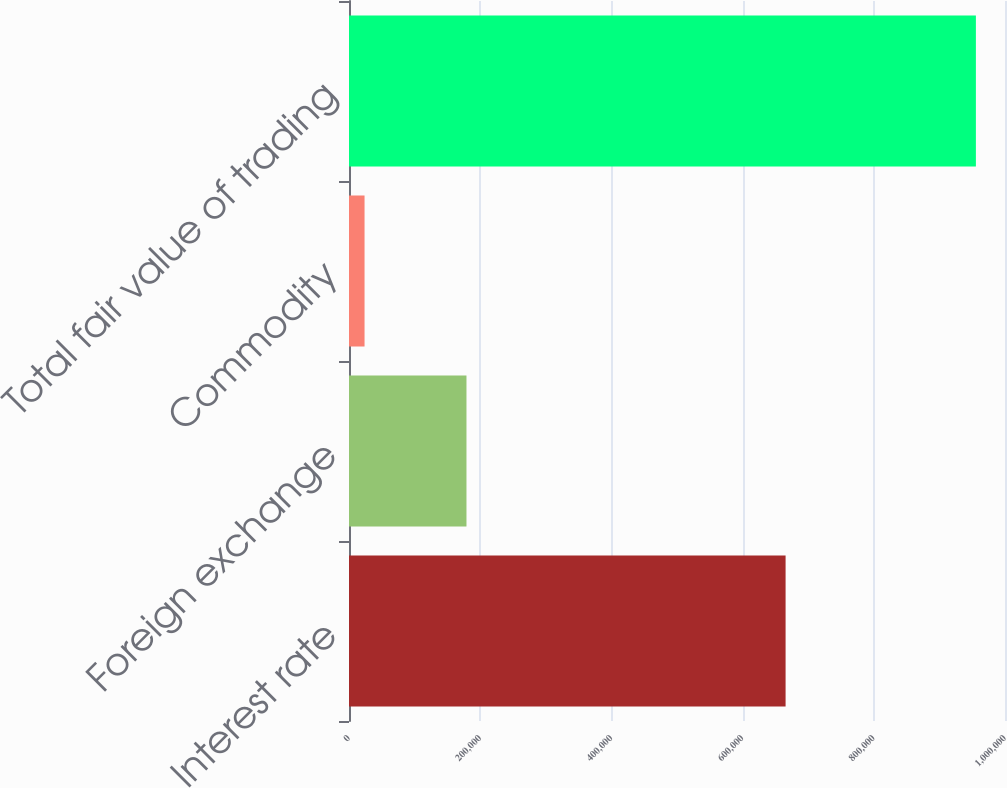Convert chart. <chart><loc_0><loc_0><loc_500><loc_500><bar_chart><fcel>Interest rate<fcel>Foreign exchange<fcel>Commodity<fcel>Total fair value of trading<nl><fcel>665531<fcel>179072<fcel>23713<fcel>955643<nl></chart> 